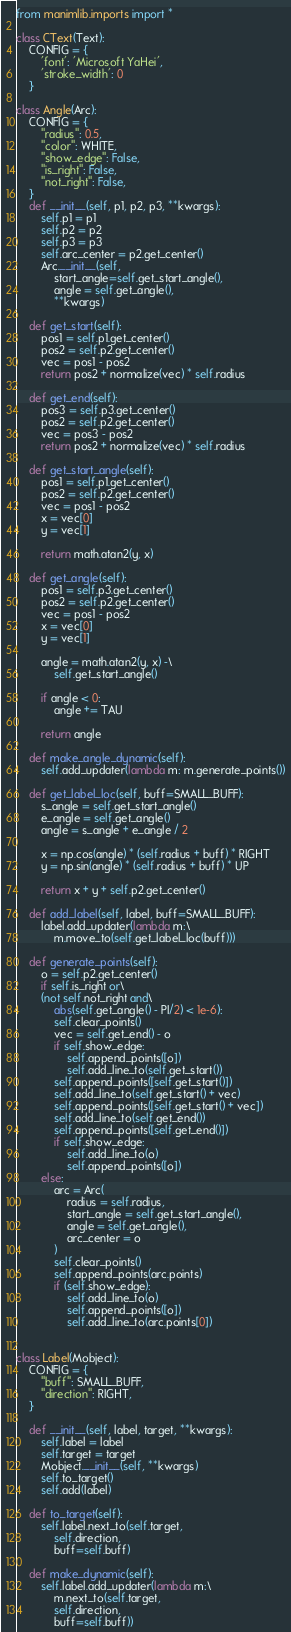<code> <loc_0><loc_0><loc_500><loc_500><_Python_>from manimlib.imports import *

class CText(Text):
    CONFIG = {
        'font': 'Microsoft YaHei',
        'stroke_width': 0
    }

class Angle(Arc):
    CONFIG = {
        "radius": 0.5,
        "color": WHITE,
        "show_edge": False,
        "is_right": False,
        "not_right": False,
    }
    def __init__(self, p1, p2, p3, **kwargs):
        self.p1 = p1
        self.p2 = p2
        self.p3 = p3
        self.arc_center = p2.get_center()
        Arc.__init__(self,
            start_angle=self.get_start_angle(),
            angle = self.get_angle(),
            **kwargs)

    def get_start(self):
        pos1 = self.p1.get_center()
        pos2 = self.p2.get_center()
        vec = pos1 - pos2
        return pos2 + normalize(vec) * self.radius
    
    def get_end(self):
        pos3 = self.p3.get_center()
        pos2 = self.p2.get_center()
        vec = pos3 - pos2
        return pos2 + normalize(vec) * self.radius

    def get_start_angle(self):
        pos1 = self.p1.get_center()
        pos2 = self.p2.get_center()
        vec = pos1 - pos2
        x = vec[0]
        y = vec[1]

        return math.atan2(y, x)

    def get_angle(self):
        pos1 = self.p3.get_center()
        pos2 = self.p2.get_center()
        vec = pos1 - pos2
        x = vec[0]
        y = vec[1]

        angle = math.atan2(y, x) -\
            self.get_start_angle()
        
        if angle < 0:
            angle += TAU
        
        return angle

    def make_angle_dynamic(self):
        self.add_updater(lambda m: m.generate_points())

    def get_label_loc(self, buff=SMALL_BUFF):
        s_angle = self.get_start_angle()
        e_angle = self.get_angle()
        angle = s_angle + e_angle / 2

        x = np.cos(angle) * (self.radius + buff) * RIGHT
        y = np.sin(angle) * (self.radius + buff) * UP

        return x + y + self.p2.get_center()

    def add_label(self, label, buff=SMALL_BUFF):
        label.add_updater(lambda m:\
            m.move_to(self.get_label_loc(buff)))

    def generate_points(self):
        o = self.p2.get_center()
        if self.is_right or\
        (not self.not_right and\
            abs(self.get_angle() - PI/2) < 1e-6):
            self.clear_points()
            vec = self.get_end() - o
            if self.show_edge:
                self.append_points([o])
                self.add_line_to(self.get_start())
            self.append_points([self.get_start()])
            self.add_line_to(self.get_start() + vec)
            self.append_points([self.get_start() + vec])
            self.add_line_to(self.get_end())
            self.append_points([self.get_end()])
            if self.show_edge:
                self.add_line_to(o)
                self.append_points([o])
        else:
            arc = Arc(
                radius = self.radius,
                start_angle = self.get_start_angle(),
                angle = self.get_angle(),
                arc_center = o
            )
            self.clear_points()
            self.append_points(arc.points)
            if (self.show_edge):
                self.add_line_to(o)
                self.append_points([o])
                self.add_line_to(arc.points[0])


class Label(Mobject):
    CONFIG = {
        "buff": SMALL_BUFF,
        "direction": RIGHT,
    }

    def __init__(self, label, target, **kwargs):
        self.label = label
        self.target = target
        Mobject.__init__(self, **kwargs)
        self.to_target()
        self.add(label)
        
    def to_target(self):
        self.label.next_to(self.target,
            self.direction,
            buff=self.buff)
    
    def make_dynamic(self):
        self.label.add_updater(lambda m:\
            m.next_to(self.target,
            self.direction,
            buff=self.buff))

</code> 